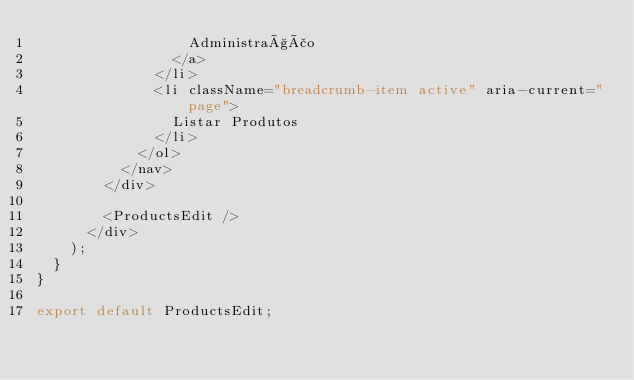<code> <loc_0><loc_0><loc_500><loc_500><_JavaScript_>                  Administração
                </a>
              </li>
              <li className="breadcrumb-item active" aria-current="page">
                Listar Produtos
              </li>
            </ol>
          </nav>
        </div>

        <ProductsEdit />
      </div>
    );
  }
}

export default ProductsEdit;
</code> 